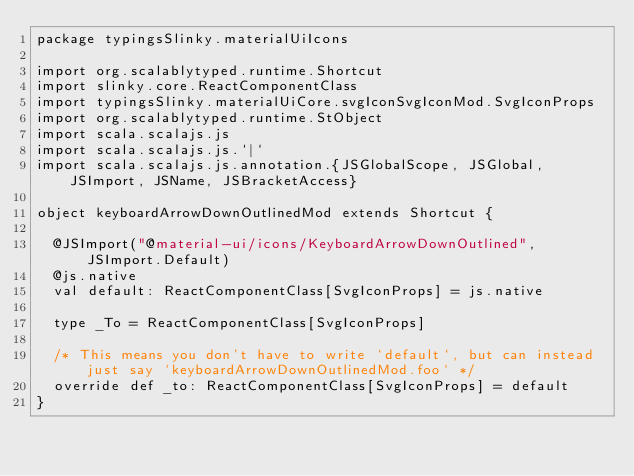<code> <loc_0><loc_0><loc_500><loc_500><_Scala_>package typingsSlinky.materialUiIcons

import org.scalablytyped.runtime.Shortcut
import slinky.core.ReactComponentClass
import typingsSlinky.materialUiCore.svgIconSvgIconMod.SvgIconProps
import org.scalablytyped.runtime.StObject
import scala.scalajs.js
import scala.scalajs.js.`|`
import scala.scalajs.js.annotation.{JSGlobalScope, JSGlobal, JSImport, JSName, JSBracketAccess}

object keyboardArrowDownOutlinedMod extends Shortcut {
  
  @JSImport("@material-ui/icons/KeyboardArrowDownOutlined", JSImport.Default)
  @js.native
  val default: ReactComponentClass[SvgIconProps] = js.native
  
  type _To = ReactComponentClass[SvgIconProps]
  
  /* This means you don't have to write `default`, but can instead just say `keyboardArrowDownOutlinedMod.foo` */
  override def _to: ReactComponentClass[SvgIconProps] = default
}
</code> 